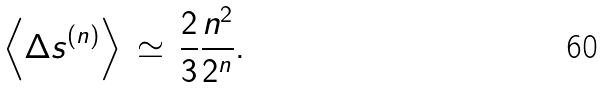Convert formula to latex. <formula><loc_0><loc_0><loc_500><loc_500>\left < \Delta s ^ { ( n ) } \right > \, \simeq \, \frac { 2 } { 3 } \frac { n ^ { 2 } } { 2 ^ { n } } .</formula> 